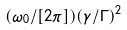<formula> <loc_0><loc_0><loc_500><loc_500>( \omega _ { 0 } / [ 2 \pi ] ) ( \gamma / \Gamma ) ^ { 2 }</formula> 